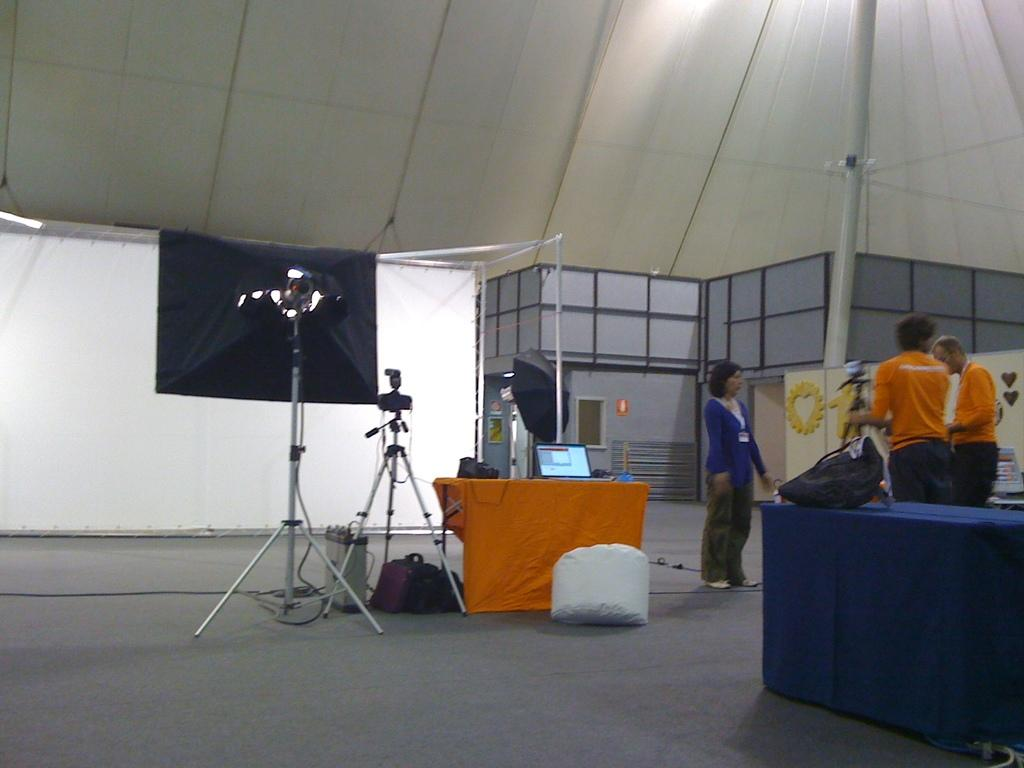How many people are in the image? There are three persons in the image. What can be seen on the table in the image? There is a tablecloth in the image. What items are present that might be used for carrying or storage? There are bags in the image. What object is used for protection from rain or sun? There is an umbrella in the image. What structures are present that might be used for displaying items or supporting equipment? There are stands in the image. What device is used for capturing images in the image? There is a camera in the image. What objects provide illumination in the image? There are lights in the image. What vertical structure is present in the image? There is a pole in the image. What color cloth is visible in the image? There is a white color cloth in the image. What type of architectural feature is present in the image? There is a wall in the image. What decision did the sister make at the hour depicted in the image? There is no mention of a sister or a specific hour in the image, so it is not possible to answer this question. 